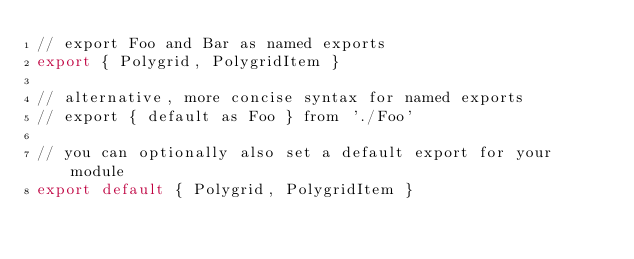Convert code to text. <code><loc_0><loc_0><loc_500><loc_500><_JavaScript_>// export Foo and Bar as named exports
export { Polygrid, PolygridItem }

// alternative, more concise syntax for named exports
// export { default as Foo } from './Foo'

// you can optionally also set a default export for your module
export default { Polygrid, PolygridItem }
</code> 